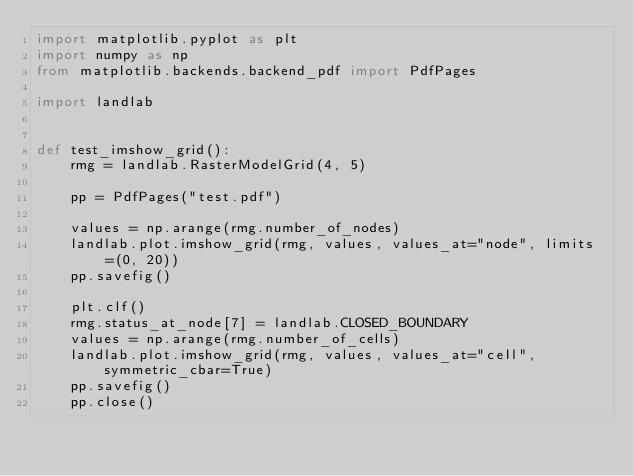Convert code to text. <code><loc_0><loc_0><loc_500><loc_500><_Python_>import matplotlib.pyplot as plt
import numpy as np
from matplotlib.backends.backend_pdf import PdfPages

import landlab


def test_imshow_grid():
    rmg = landlab.RasterModelGrid(4, 5)

    pp = PdfPages("test.pdf")

    values = np.arange(rmg.number_of_nodes)
    landlab.plot.imshow_grid(rmg, values, values_at="node", limits=(0, 20))
    pp.savefig()

    plt.clf()
    rmg.status_at_node[7] = landlab.CLOSED_BOUNDARY
    values = np.arange(rmg.number_of_cells)
    landlab.plot.imshow_grid(rmg, values, values_at="cell", symmetric_cbar=True)
    pp.savefig()
    pp.close()
</code> 